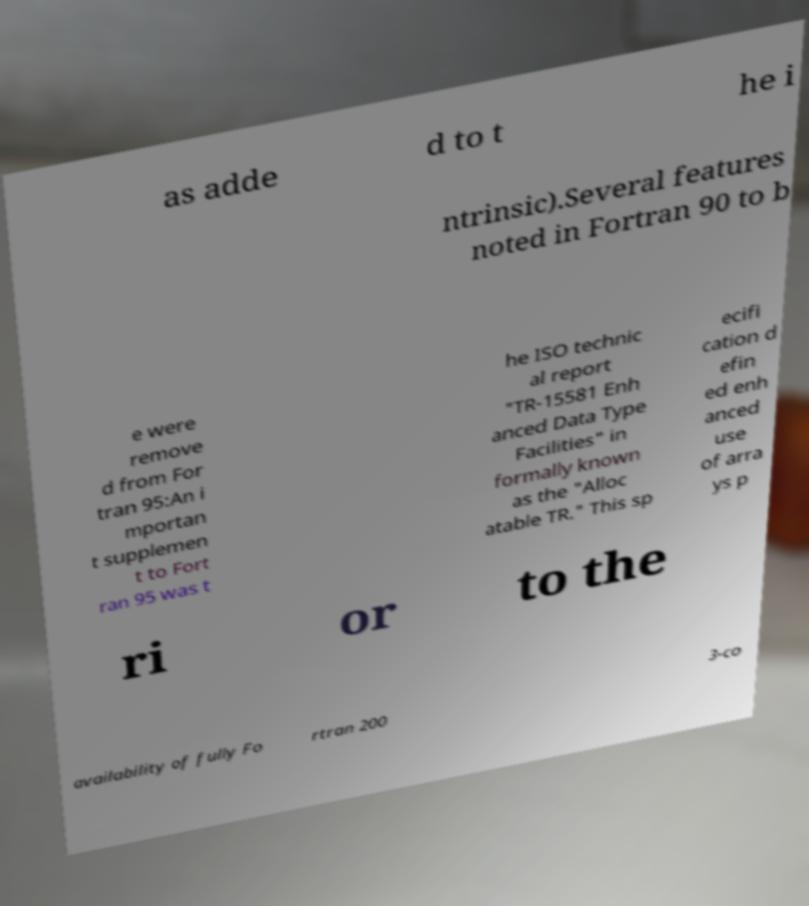What messages or text are displayed in this image? I need them in a readable, typed format. as adde d to t he i ntrinsic).Several features noted in Fortran 90 to b e were remove d from For tran 95:An i mportan t supplemen t to Fort ran 95 was t he ISO technic al report "TR-15581 Enh anced Data Type Facilities" in formally known as the "Alloc atable TR." This sp ecifi cation d efin ed enh anced use of arra ys p ri or to the availability of fully Fo rtran 200 3-co 